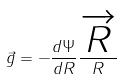<formula> <loc_0><loc_0><loc_500><loc_500>\vec { g } = - \frac { d \Psi } { d R } \frac { \overrightarrow { R } } { R }</formula> 